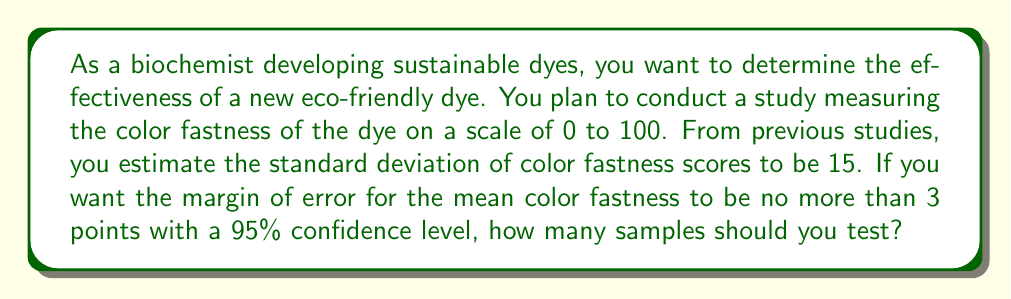Can you solve this math problem? To determine the sample size needed for a desired margin of error, we can use the formula:

$$n = \left(\frac{z_{\alpha/2} \cdot \sigma}{E}\right)^2$$

Where:
$n$ = required sample size
$z_{\alpha/2}$ = critical value for the desired confidence level
$\sigma$ = population standard deviation
$E$ = desired margin of error

Step 1: Identify the known values
- Confidence level = 95%, so $z_{\alpha/2} = 1.96$
- Standard deviation $\sigma = 15$
- Desired margin of error $E = 3$

Step 2: Plug the values into the formula
$$n = \left(\frac{1.96 \cdot 15}{3}\right)^2$$

Step 3: Calculate the result
$$n = (9.8)^2 = 96.04$$

Step 4: Round up to the nearest whole number
Since we can't test a fractional sample, we round up to ensure we meet or exceed the desired precision.

$n = 97$
Answer: 97 samples 